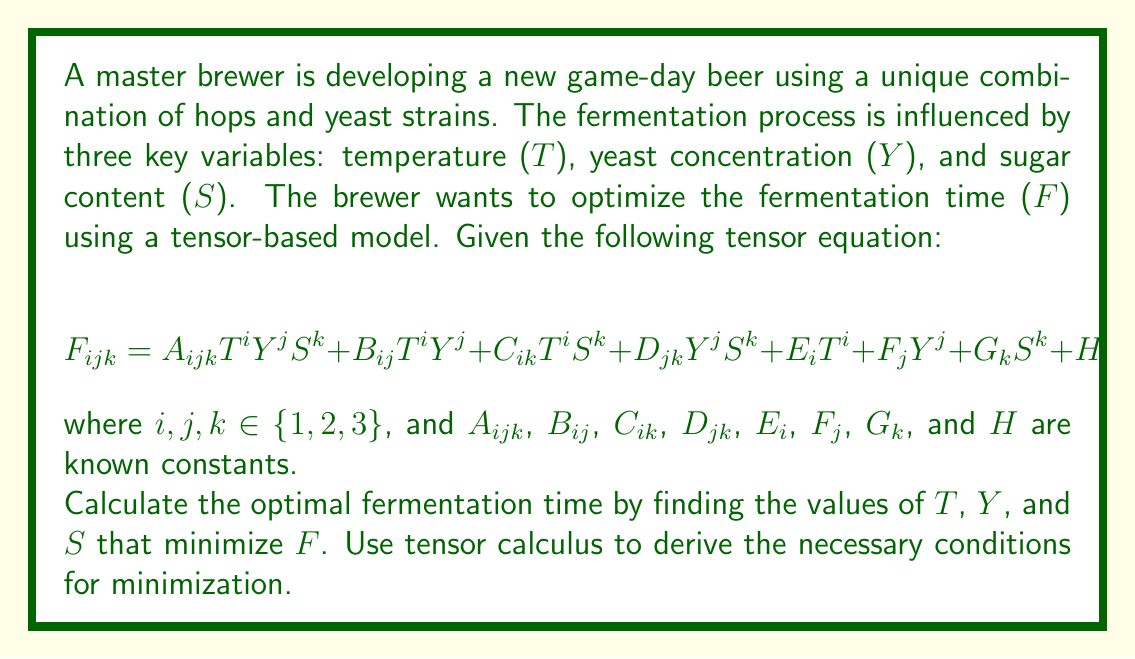Provide a solution to this math problem. To find the optimal fermentation time, we need to minimize the function F with respect to T, Y, and S. We'll use tensor calculus to derive the necessary conditions for minimization.

Step 1: Calculate the partial derivatives of F with respect to T, Y, and S.

$$\frac{\partial F}{\partial T} = i A_{ijk}T^{i-1} Y^j S^k + i B_{ij}T^{i-1} Y^j + i C_{ik}T^{i-1} S^k + i E_i T^{i-1}$$

$$\frac{\partial F}{\partial Y} = j A_{ijk}T^i Y^{j-1} S^k + j B_{ij}T^i Y^{j-1} + j D_{jk}Y^{j-1} S^k + j F_j Y^{j-1}$$

$$\frac{\partial F}{\partial S} = k A_{ijk}T^i Y^j S^{k-1} + k C_{ik}T^i S^{k-1} + k D_{jk}Y^j S^{k-1} + k G_k S^{k-1}$$

Step 2: Set each partial derivative to zero to find the critical points.

$$i A_{ijk}T^{i-1} Y^j S^k + i B_{ij}T^{i-1} Y^j + i C_{ik}T^{i-1} S^k + i E_i T^{i-1} = 0$$

$$j A_{ijk}T^i Y^{j-1} S^k + j B_{ij}T^i Y^{j-1} + j D_{jk}Y^{j-1} S^k + j F_j Y^{j-1} = 0$$

$$k A_{ijk}T^i Y^j S^{k-1} + k C_{ik}T^i S^{k-1} + k D_{jk}Y^j S^{k-1} + k G_k S^{k-1} = 0$$

Step 3: Solve the system of equations to find the values of T, Y, and S that satisfy all three conditions simultaneously. This will require numerical methods due to the complexity of the equations.

Step 4: Once the values of T, Y, and S are found, calculate the second-order partial derivatives to confirm that the critical point is indeed a minimum:

$$\frac{\partial^2 F}{\partial T^2}, \frac{\partial^2 F}{\partial Y^2}, \frac{\partial^2 F}{\partial S^2}, \frac{\partial^2 F}{\partial T \partial Y}, \frac{\partial^2 F}{\partial T \partial S}, \frac{\partial^2 F}{\partial Y \partial S}$$

Step 5: Evaluate the Hessian matrix at the critical point to ensure it is positive definite, confirming a local minimum.

Step 6: Substitute the optimal values of T, Y, and S into the original equation to find the minimal fermentation time F.

The exact solution depends on the specific values of the constants in the tensor equation. However, this process provides the necessary steps to find the optimal fermentation time using multivariable tensor analysis.
Answer: $(T^*, Y^*, S^*)$ that satisfies $\nabla F = 0$ and positive definite Hessian 